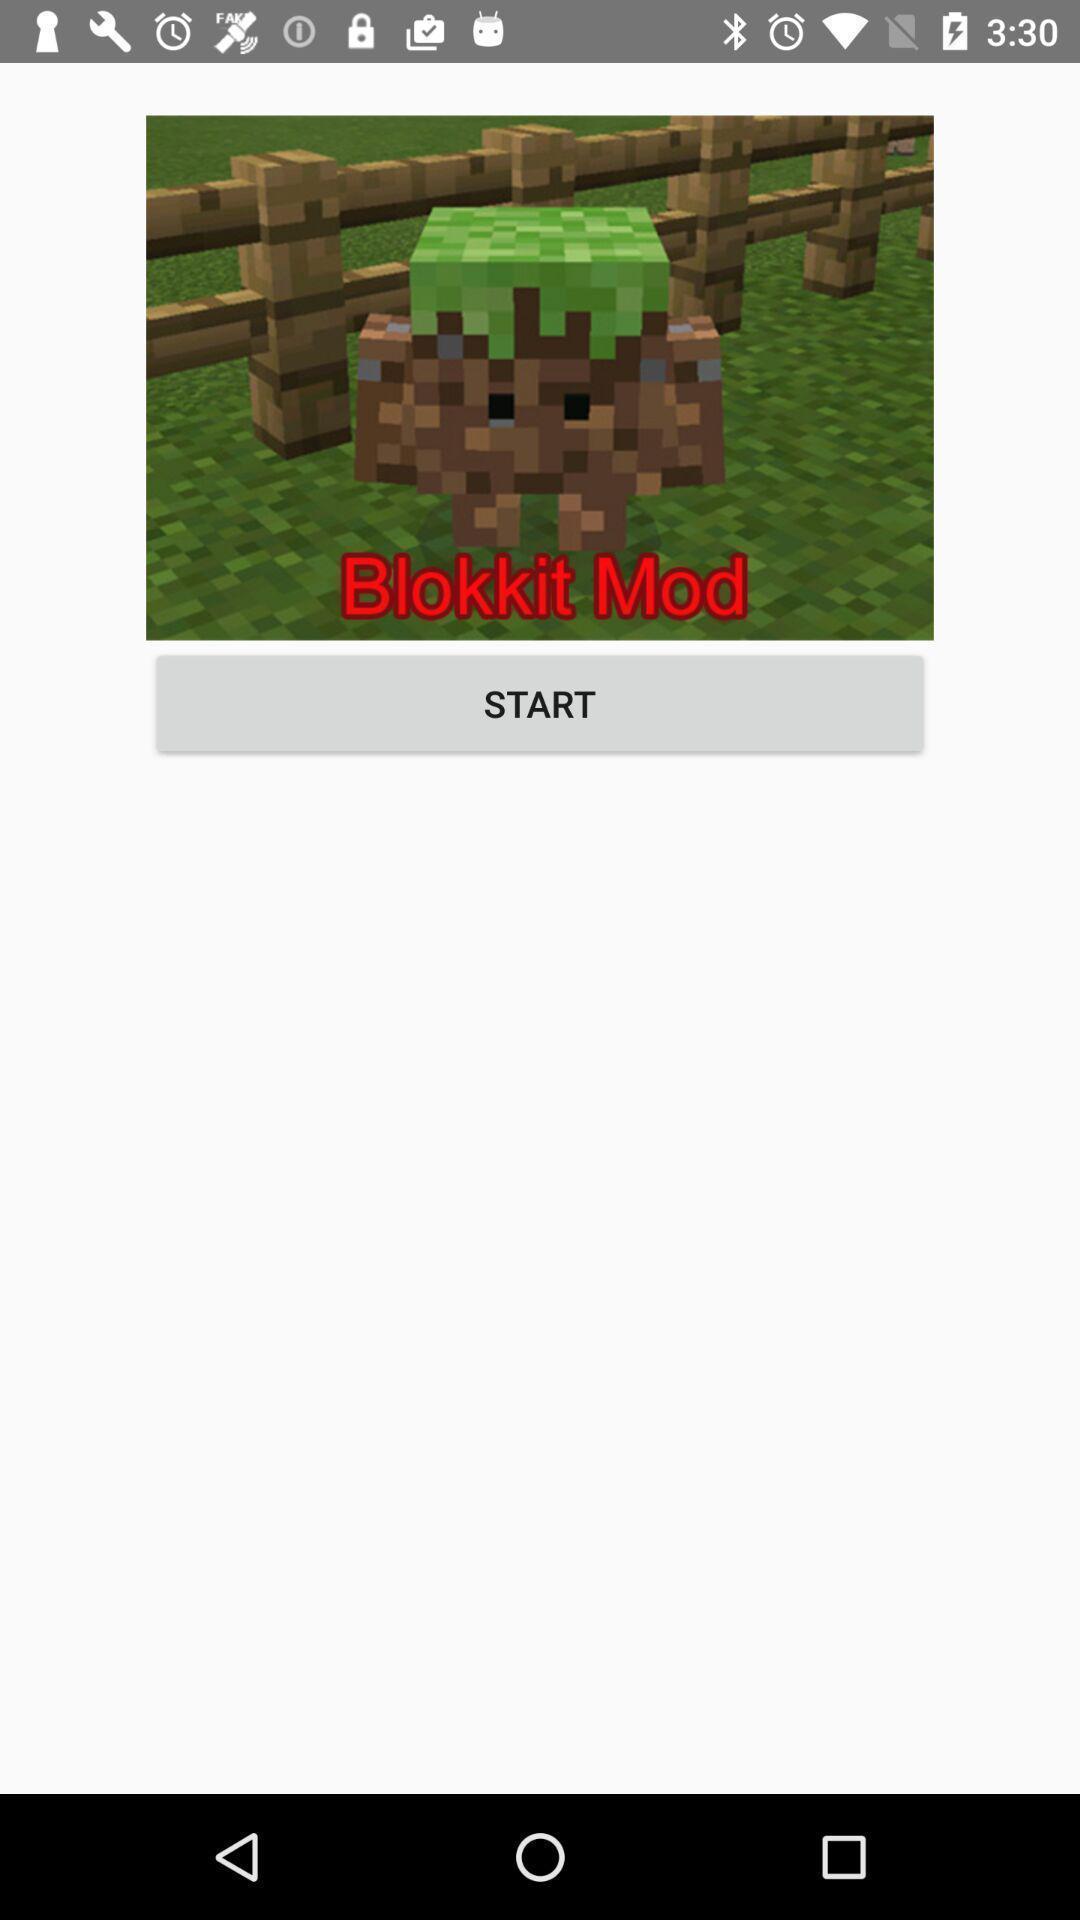Provide a textual representation of this image. Start option displaying. 